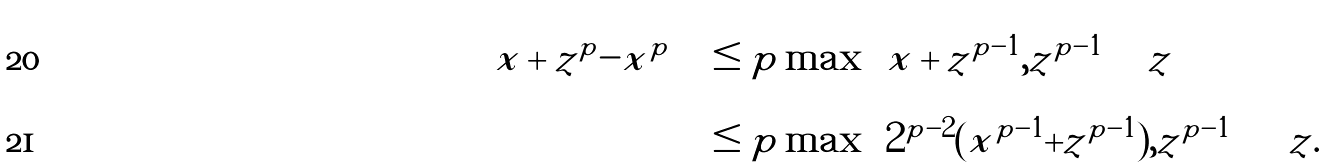Convert formula to latex. <formula><loc_0><loc_0><loc_500><loc_500>\left | | x + z | ^ { p } - | x | ^ { p } \right | & \leq p \max \left \{ | x + z | ^ { p - 1 } , | z | ^ { p - 1 } \right \} | z | \\ & \leq p \max \left \{ 2 ^ { p - 2 } ( | x | ^ { p - 1 } + | z | ^ { p - 1 } ) , | z | ^ { p - 1 } \right \} | z | .</formula> 